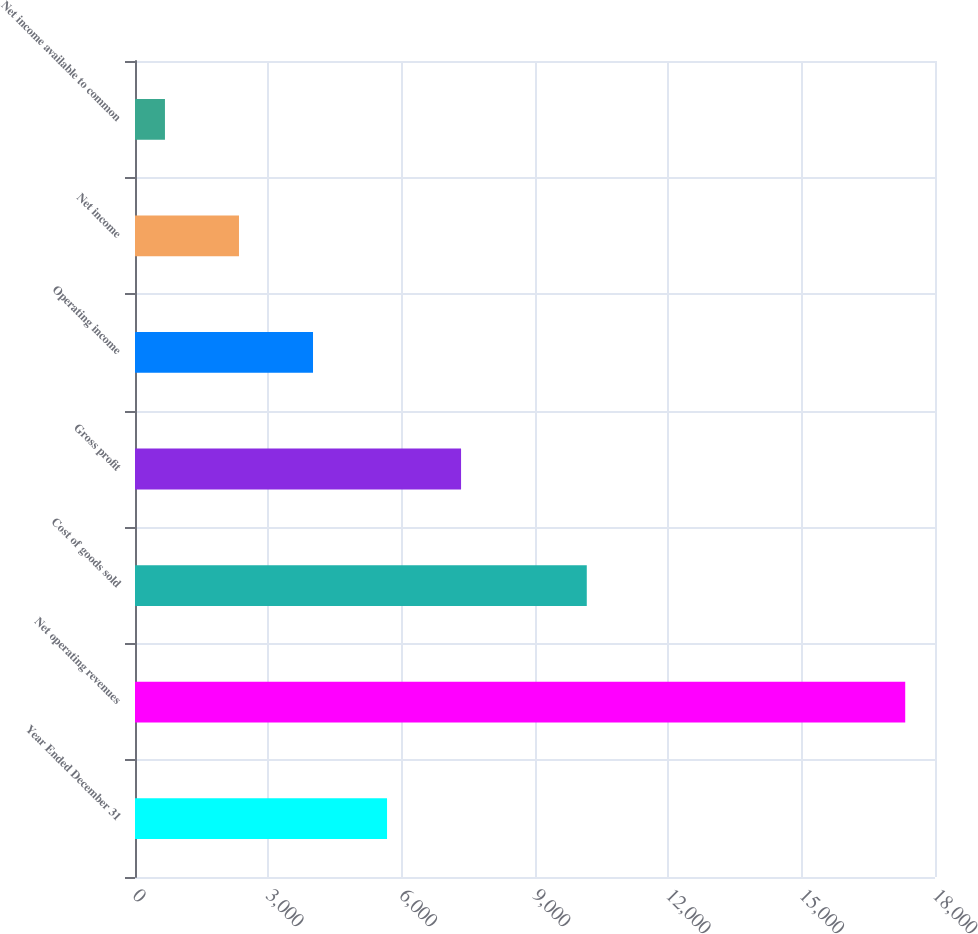<chart> <loc_0><loc_0><loc_500><loc_500><bar_chart><fcel>Year Ended December 31<fcel>Net operating revenues<fcel>Cost of goods sold<fcel>Gross profit<fcel>Operating income<fcel>Net income<fcel>Net income available to common<nl><fcel>5670.8<fcel>17330<fcel>10165<fcel>7336.4<fcel>4005.2<fcel>2339.6<fcel>674<nl></chart> 